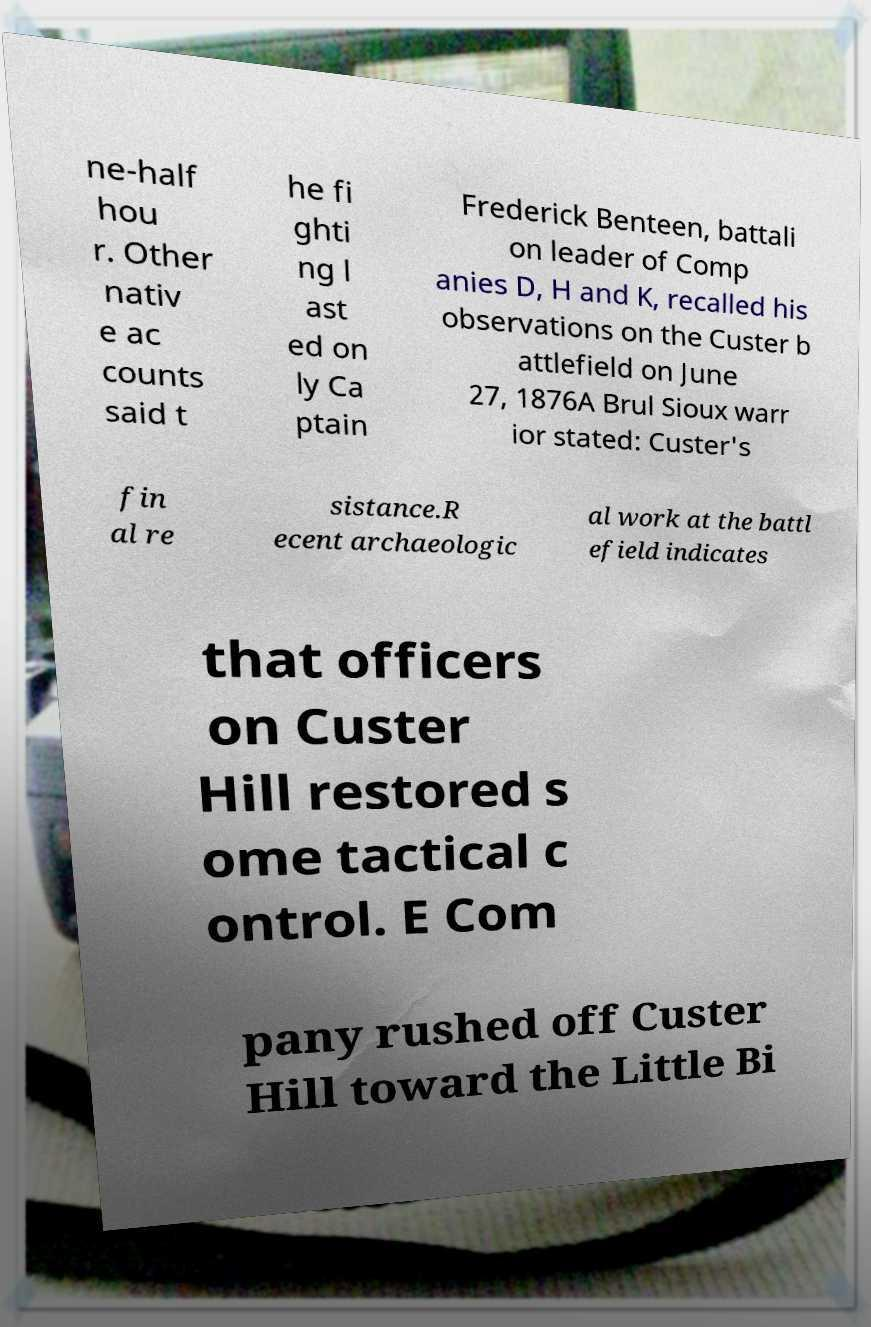Could you extract and type out the text from this image? ne-half hou r. Other nativ e ac counts said t he fi ghti ng l ast ed on ly Ca ptain Frederick Benteen, battali on leader of Comp anies D, H and K, recalled his observations on the Custer b attlefield on June 27, 1876A Brul Sioux warr ior stated: Custer's fin al re sistance.R ecent archaeologic al work at the battl efield indicates that officers on Custer Hill restored s ome tactical c ontrol. E Com pany rushed off Custer Hill toward the Little Bi 